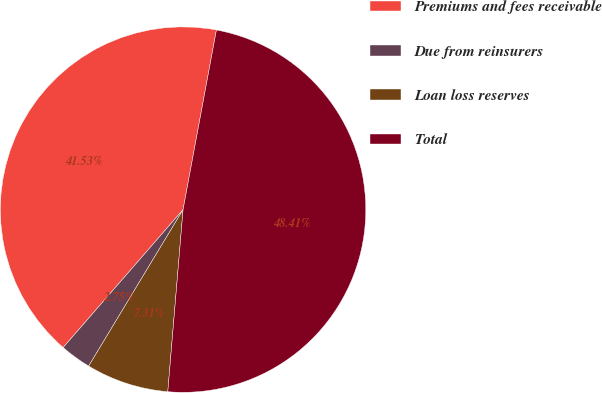Convert chart. <chart><loc_0><loc_0><loc_500><loc_500><pie_chart><fcel>Premiums and fees receivable<fcel>Due from reinsurers<fcel>Loan loss reserves<fcel>Total<nl><fcel>41.53%<fcel>2.75%<fcel>7.31%<fcel>48.41%<nl></chart> 